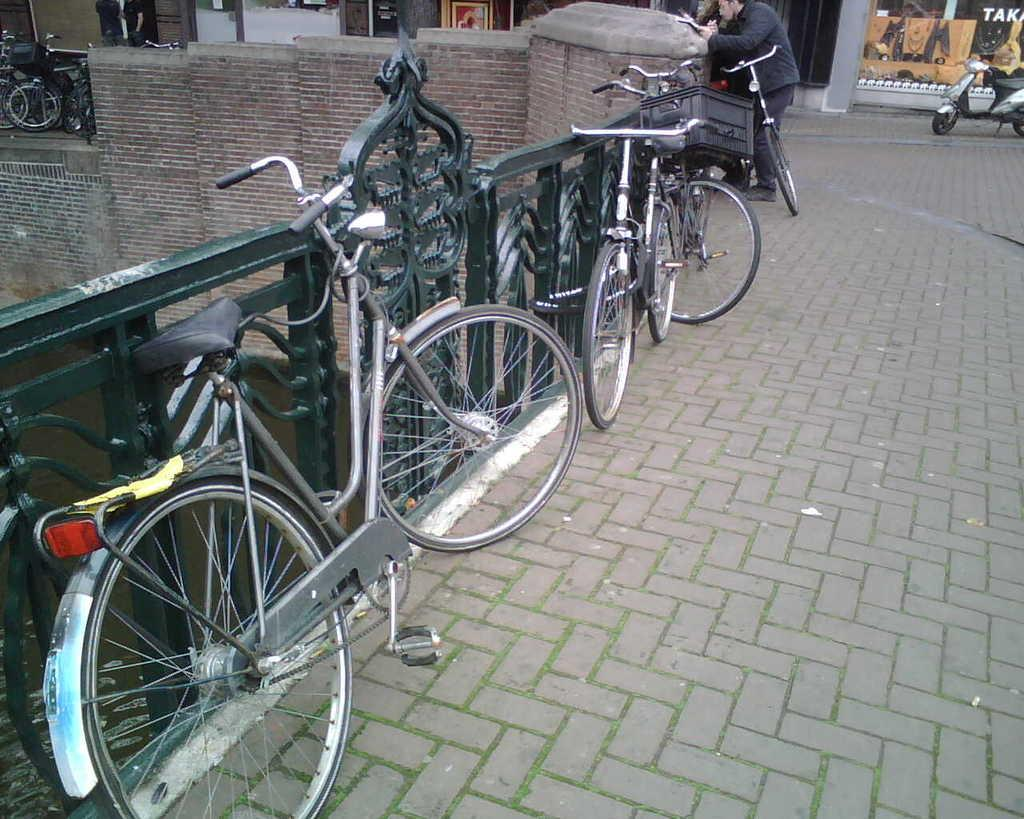What type of vehicles are present in the image? There are bicycles and a motorbike in the image. What natural element can be seen in the image? There is water visible in the image. What type of structure is present in the image? There is a wall in the image. What type of path is visible in the image? There is a footpath in the image. Who is present in the image? A: There is a man standing in the image. What can be seen in the background of the image? There are posters in the background of the image. What is the average income of the stone in the image? There is no stone present in the image, so it is not possible to determine its average income. 